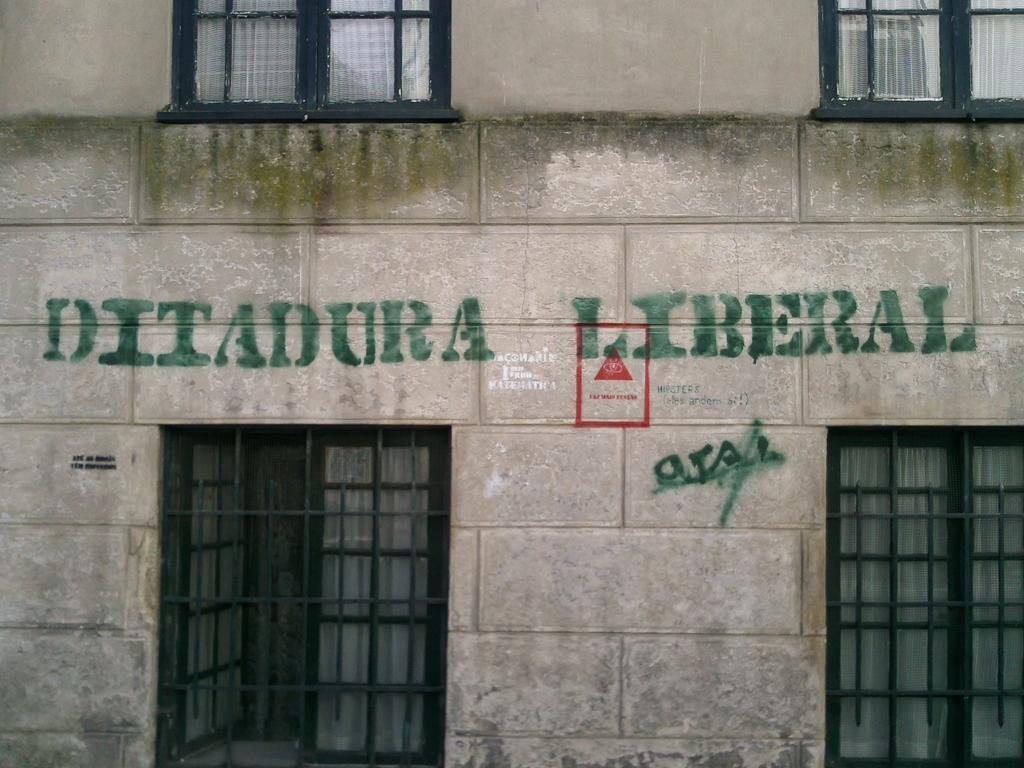What type of architectural feature is present in the image? There are windows in the image, which belong to a building. What can be seen on the wall of the building? There is a symbol and text on the wall of the building. How many eyes can be seen on the beetle in the image? There is no beetle present in the image, so it is not possible to determine the number of eyes. 